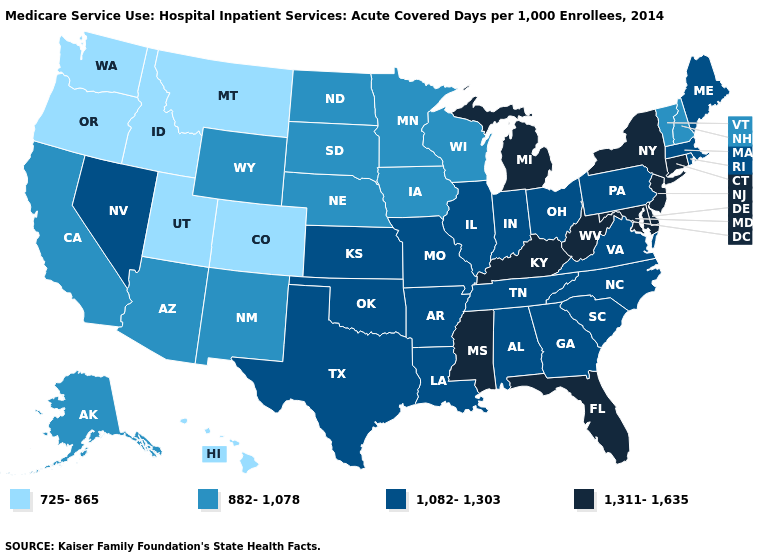Which states have the highest value in the USA?
Write a very short answer. Connecticut, Delaware, Florida, Kentucky, Maryland, Michigan, Mississippi, New Jersey, New York, West Virginia. Does the first symbol in the legend represent the smallest category?
Keep it brief. Yes. Name the states that have a value in the range 725-865?
Give a very brief answer. Colorado, Hawaii, Idaho, Montana, Oregon, Utah, Washington. Which states hav the highest value in the MidWest?
Answer briefly. Michigan. Does the first symbol in the legend represent the smallest category?
Quick response, please. Yes. What is the highest value in the MidWest ?
Quick response, please. 1,311-1,635. What is the highest value in the USA?
Concise answer only. 1,311-1,635. What is the value of Mississippi?
Answer briefly. 1,311-1,635. Does New Mexico have the same value as Florida?
Give a very brief answer. No. What is the highest value in the West ?
Quick response, please. 1,082-1,303. Name the states that have a value in the range 1,082-1,303?
Answer briefly. Alabama, Arkansas, Georgia, Illinois, Indiana, Kansas, Louisiana, Maine, Massachusetts, Missouri, Nevada, North Carolina, Ohio, Oklahoma, Pennsylvania, Rhode Island, South Carolina, Tennessee, Texas, Virginia. Among the states that border Alabama , which have the highest value?
Answer briefly. Florida, Mississippi. What is the value of Vermont?
Write a very short answer. 882-1,078. What is the value of Nevada?
Keep it brief. 1,082-1,303. Is the legend a continuous bar?
Keep it brief. No. 